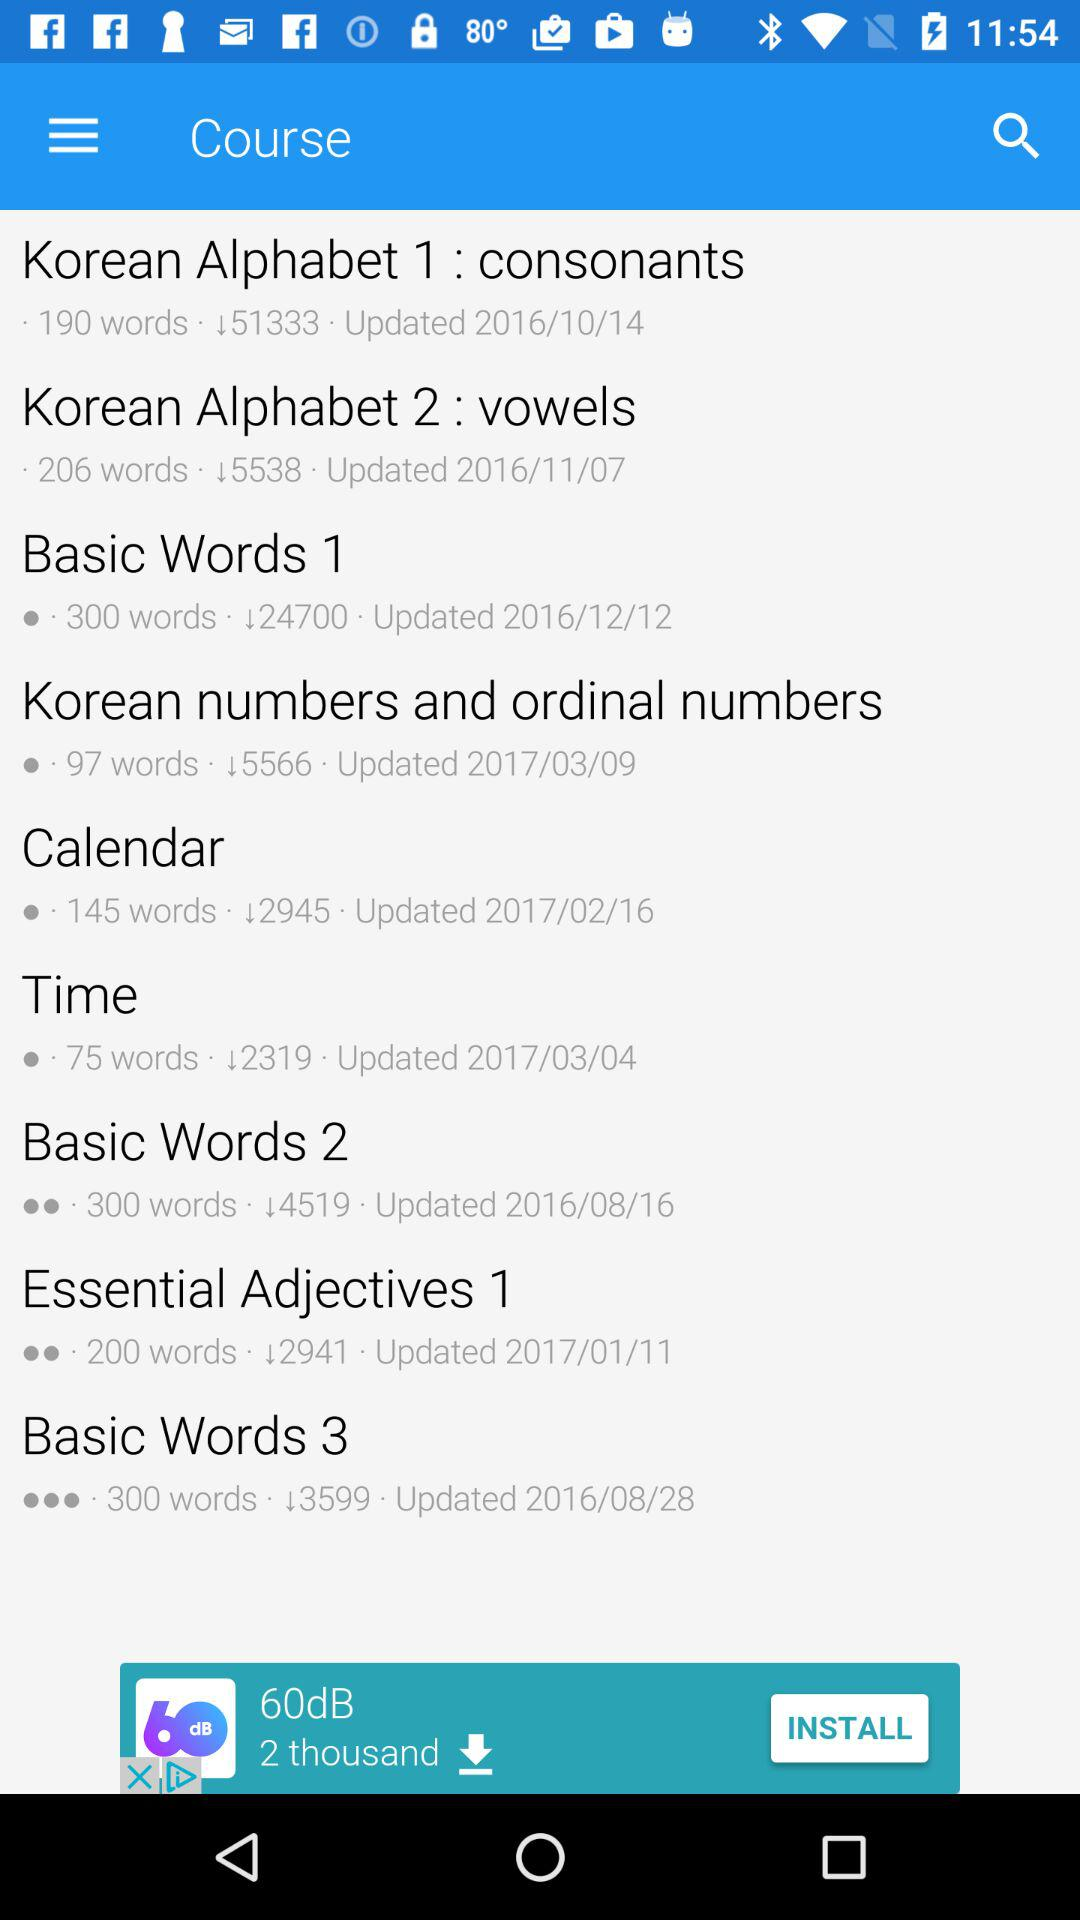When was the "Korean Alphabet 2" updated? The "Korean Alphabet 2" was updated on November 7, 2016. 